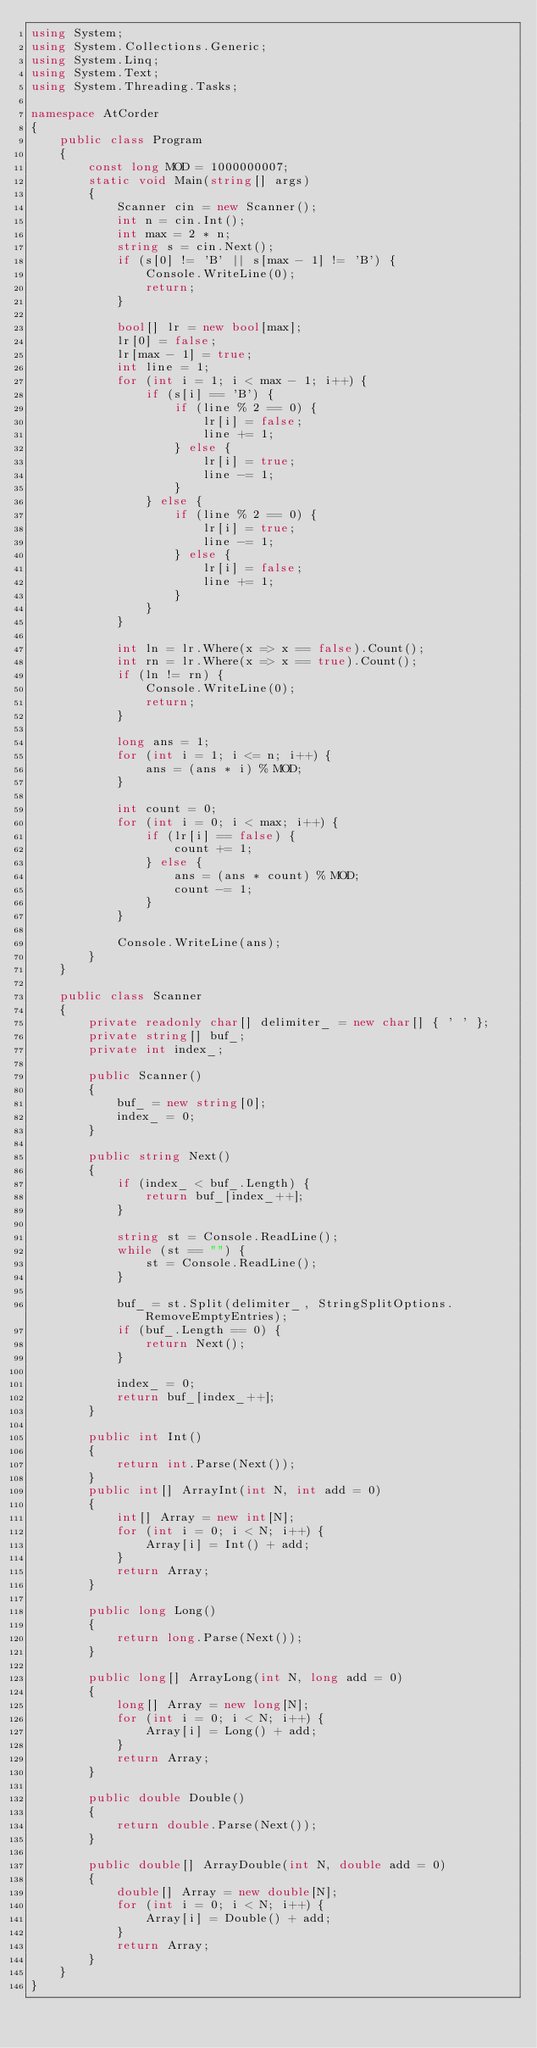Convert code to text. <code><loc_0><loc_0><loc_500><loc_500><_C#_>using System;
using System.Collections.Generic;
using System.Linq;
using System.Text;
using System.Threading.Tasks;

namespace AtCorder
{
	public class Program
	{
		const long MOD = 1000000007;
		static void Main(string[] args)
		{
			Scanner cin = new Scanner();
			int n = cin.Int();
			int max = 2 * n;
			string s = cin.Next();
			if (s[0] != 'B' || s[max - 1] != 'B') {
				Console.WriteLine(0);
				return;
			}

			bool[] lr = new bool[max];
			lr[0] = false;
			lr[max - 1] = true;
			int line = 1;
			for (int i = 1; i < max - 1; i++) {
				if (s[i] == 'B') {
					if (line % 2 == 0) {
						lr[i] = false;
						line += 1;
					} else {
						lr[i] = true;
						line -= 1;
					}
				} else {
					if (line % 2 == 0) {
						lr[i] = true;
						line -= 1;
					} else {
						lr[i] = false;
						line += 1;
					}
				}
			}

			int ln = lr.Where(x => x == false).Count();
			int rn = lr.Where(x => x == true).Count();
			if (ln != rn) {
				Console.WriteLine(0);
				return;
			}

			long ans = 1;
			for (int i = 1; i <= n; i++) {
				ans = (ans * i) % MOD;
			}

			int count = 0;
			for (int i = 0; i < max; i++) {
				if (lr[i] == false) {
					count += 1;
				} else {
					ans = (ans * count) % MOD;
					count -= 1;
				}
			}

			Console.WriteLine(ans);
		}
	}

	public class Scanner
	{
		private readonly char[] delimiter_ = new char[] { ' ' };
		private string[] buf_;
		private int index_;

		public Scanner()
		{
			buf_ = new string[0];
			index_ = 0;
		}

		public string Next()
		{
			if (index_ < buf_.Length) {
				return buf_[index_++];
			}

			string st = Console.ReadLine();
			while (st == "") {
				st = Console.ReadLine();
			}

			buf_ = st.Split(delimiter_, StringSplitOptions.RemoveEmptyEntries);
			if (buf_.Length == 0) {
				return Next();
			}

			index_ = 0;
			return buf_[index_++];
		}

		public int Int()
		{
			return int.Parse(Next());
		}
		public int[] ArrayInt(int N, int add = 0)
		{
			int[] Array = new int[N];
			for (int i = 0; i < N; i++) {
				Array[i] = Int() + add;
			}
			return Array;
		}

		public long Long()
		{
			return long.Parse(Next());
		}

		public long[] ArrayLong(int N, long add = 0)
		{
			long[] Array = new long[N];
			for (int i = 0; i < N; i++) {
				Array[i] = Long() + add;
			}
			return Array;
		}

		public double Double()
		{
			return double.Parse(Next());
		}

		public double[] ArrayDouble(int N, double add = 0)
		{
			double[] Array = new double[N];
			for (int i = 0; i < N; i++) {
				Array[i] = Double() + add;
			}
			return Array;
		}
	}
}</code> 